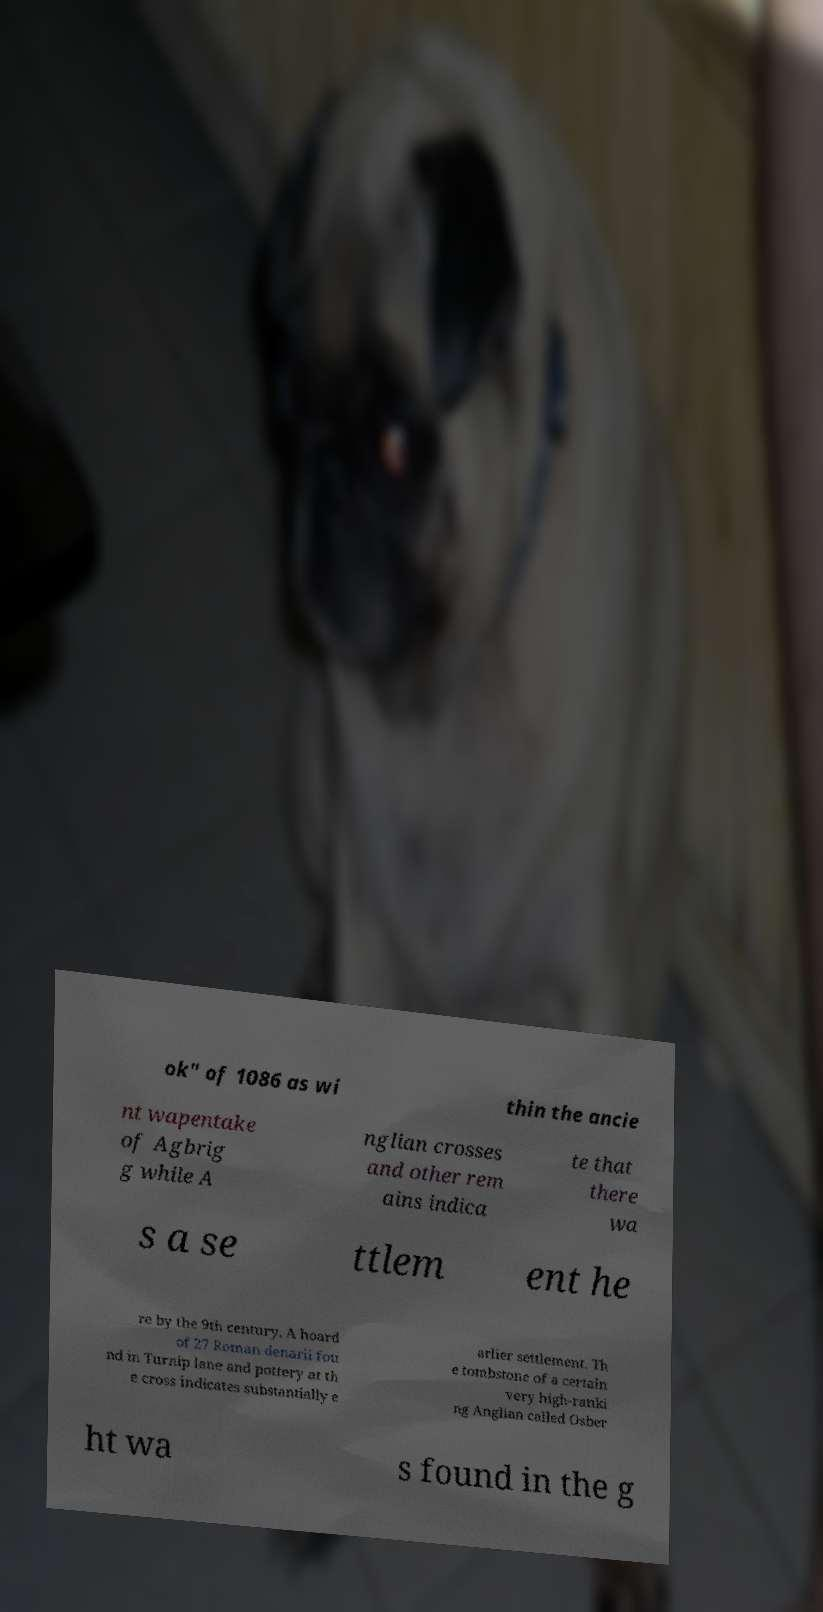I need the written content from this picture converted into text. Can you do that? ok" of 1086 as wi thin the ancie nt wapentake of Agbrig g while A nglian crosses and other rem ains indica te that there wa s a se ttlem ent he re by the 9th century. A hoard of 27 Roman denarii fou nd in Turnip lane and pottery at th e cross indicates substantially e arlier settlement. Th e tombstone of a certain very high-ranki ng Anglian called Osber ht wa s found in the g 